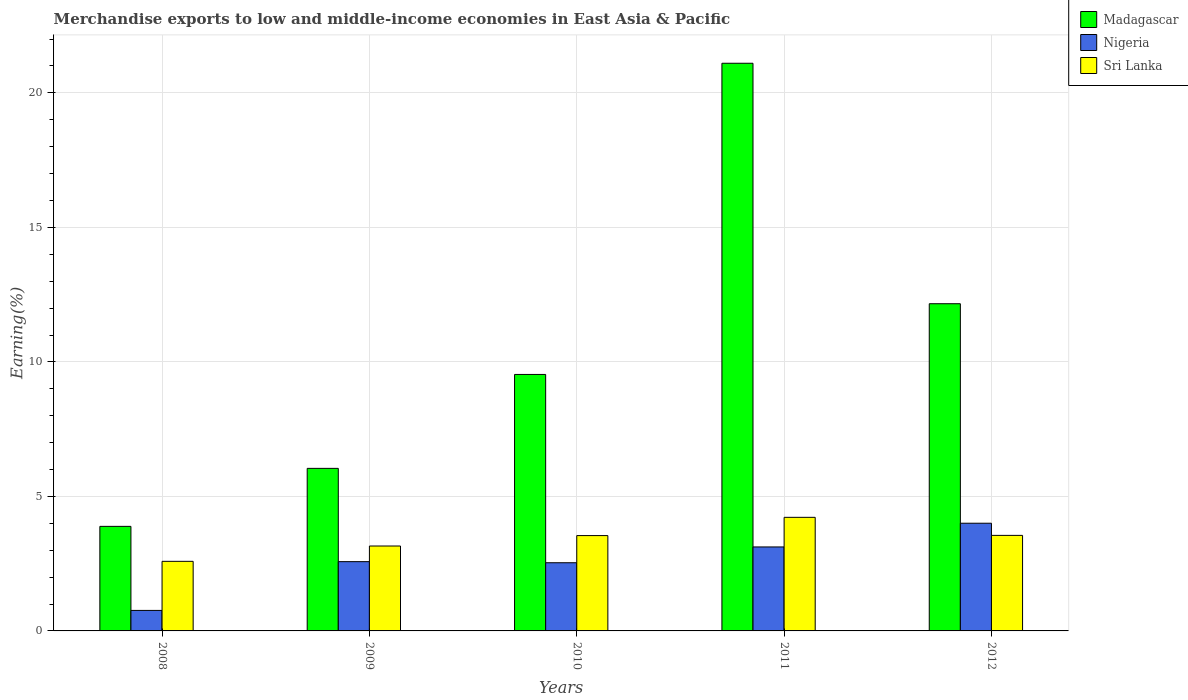How many different coloured bars are there?
Provide a short and direct response. 3. Are the number of bars per tick equal to the number of legend labels?
Your response must be concise. Yes. Are the number of bars on each tick of the X-axis equal?
Ensure brevity in your answer.  Yes. How many bars are there on the 4th tick from the left?
Your response must be concise. 3. How many bars are there on the 2nd tick from the right?
Your answer should be very brief. 3. What is the label of the 4th group of bars from the left?
Your answer should be compact. 2011. What is the percentage of amount earned from merchandise exports in Sri Lanka in 2008?
Give a very brief answer. 2.59. Across all years, what is the maximum percentage of amount earned from merchandise exports in Nigeria?
Offer a terse response. 4. Across all years, what is the minimum percentage of amount earned from merchandise exports in Nigeria?
Make the answer very short. 0.76. What is the total percentage of amount earned from merchandise exports in Sri Lanka in the graph?
Offer a terse response. 17.06. What is the difference between the percentage of amount earned from merchandise exports in Sri Lanka in 2008 and that in 2012?
Ensure brevity in your answer.  -0.96. What is the difference between the percentage of amount earned from merchandise exports in Madagascar in 2011 and the percentage of amount earned from merchandise exports in Nigeria in 2010?
Offer a terse response. 18.57. What is the average percentage of amount earned from merchandise exports in Nigeria per year?
Provide a succinct answer. 2.6. In the year 2010, what is the difference between the percentage of amount earned from merchandise exports in Madagascar and percentage of amount earned from merchandise exports in Nigeria?
Your response must be concise. 7. In how many years, is the percentage of amount earned from merchandise exports in Sri Lanka greater than 14 %?
Ensure brevity in your answer.  0. What is the ratio of the percentage of amount earned from merchandise exports in Madagascar in 2009 to that in 2011?
Provide a succinct answer. 0.29. What is the difference between the highest and the second highest percentage of amount earned from merchandise exports in Nigeria?
Make the answer very short. 0.88. What is the difference between the highest and the lowest percentage of amount earned from merchandise exports in Sri Lanka?
Provide a succinct answer. 1.64. Is the sum of the percentage of amount earned from merchandise exports in Nigeria in 2009 and 2010 greater than the maximum percentage of amount earned from merchandise exports in Sri Lanka across all years?
Your answer should be compact. Yes. What does the 2nd bar from the left in 2008 represents?
Give a very brief answer. Nigeria. What does the 2nd bar from the right in 2008 represents?
Provide a succinct answer. Nigeria. How many bars are there?
Offer a very short reply. 15. Are all the bars in the graph horizontal?
Provide a succinct answer. No. Does the graph contain grids?
Your answer should be very brief. Yes. Where does the legend appear in the graph?
Keep it short and to the point. Top right. How many legend labels are there?
Ensure brevity in your answer.  3. What is the title of the graph?
Make the answer very short. Merchandise exports to low and middle-income economies in East Asia & Pacific. What is the label or title of the Y-axis?
Give a very brief answer. Earning(%). What is the Earning(%) in Madagascar in 2008?
Ensure brevity in your answer.  3.89. What is the Earning(%) in Nigeria in 2008?
Give a very brief answer. 0.76. What is the Earning(%) of Sri Lanka in 2008?
Keep it short and to the point. 2.59. What is the Earning(%) of Madagascar in 2009?
Your response must be concise. 6.04. What is the Earning(%) in Nigeria in 2009?
Make the answer very short. 2.57. What is the Earning(%) of Sri Lanka in 2009?
Your answer should be compact. 3.16. What is the Earning(%) in Madagascar in 2010?
Your answer should be compact. 9.53. What is the Earning(%) of Nigeria in 2010?
Make the answer very short. 2.53. What is the Earning(%) of Sri Lanka in 2010?
Provide a succinct answer. 3.54. What is the Earning(%) in Madagascar in 2011?
Provide a succinct answer. 21.1. What is the Earning(%) of Nigeria in 2011?
Make the answer very short. 3.12. What is the Earning(%) of Sri Lanka in 2011?
Your answer should be compact. 4.22. What is the Earning(%) in Madagascar in 2012?
Keep it short and to the point. 12.16. What is the Earning(%) of Nigeria in 2012?
Your response must be concise. 4. What is the Earning(%) in Sri Lanka in 2012?
Your answer should be very brief. 3.55. Across all years, what is the maximum Earning(%) in Madagascar?
Your answer should be very brief. 21.1. Across all years, what is the maximum Earning(%) in Nigeria?
Your answer should be compact. 4. Across all years, what is the maximum Earning(%) of Sri Lanka?
Provide a short and direct response. 4.22. Across all years, what is the minimum Earning(%) of Madagascar?
Your answer should be compact. 3.89. Across all years, what is the minimum Earning(%) of Nigeria?
Ensure brevity in your answer.  0.76. Across all years, what is the minimum Earning(%) in Sri Lanka?
Ensure brevity in your answer.  2.59. What is the total Earning(%) of Madagascar in the graph?
Ensure brevity in your answer.  52.73. What is the total Earning(%) in Nigeria in the graph?
Your answer should be compact. 13. What is the total Earning(%) in Sri Lanka in the graph?
Ensure brevity in your answer.  17.06. What is the difference between the Earning(%) of Madagascar in 2008 and that in 2009?
Offer a very short reply. -2.16. What is the difference between the Earning(%) in Nigeria in 2008 and that in 2009?
Provide a short and direct response. -1.81. What is the difference between the Earning(%) in Sri Lanka in 2008 and that in 2009?
Your answer should be compact. -0.57. What is the difference between the Earning(%) of Madagascar in 2008 and that in 2010?
Ensure brevity in your answer.  -5.65. What is the difference between the Earning(%) of Nigeria in 2008 and that in 2010?
Ensure brevity in your answer.  -1.77. What is the difference between the Earning(%) of Sri Lanka in 2008 and that in 2010?
Offer a very short reply. -0.96. What is the difference between the Earning(%) in Madagascar in 2008 and that in 2011?
Make the answer very short. -17.22. What is the difference between the Earning(%) of Nigeria in 2008 and that in 2011?
Your answer should be very brief. -2.36. What is the difference between the Earning(%) in Sri Lanka in 2008 and that in 2011?
Make the answer very short. -1.64. What is the difference between the Earning(%) in Madagascar in 2008 and that in 2012?
Your response must be concise. -8.28. What is the difference between the Earning(%) in Nigeria in 2008 and that in 2012?
Provide a short and direct response. -3.24. What is the difference between the Earning(%) in Sri Lanka in 2008 and that in 2012?
Your answer should be compact. -0.96. What is the difference between the Earning(%) in Madagascar in 2009 and that in 2010?
Keep it short and to the point. -3.49. What is the difference between the Earning(%) in Nigeria in 2009 and that in 2010?
Give a very brief answer. 0.04. What is the difference between the Earning(%) in Sri Lanka in 2009 and that in 2010?
Offer a terse response. -0.39. What is the difference between the Earning(%) in Madagascar in 2009 and that in 2011?
Give a very brief answer. -15.06. What is the difference between the Earning(%) of Nigeria in 2009 and that in 2011?
Your answer should be very brief. -0.55. What is the difference between the Earning(%) in Sri Lanka in 2009 and that in 2011?
Your response must be concise. -1.07. What is the difference between the Earning(%) in Madagascar in 2009 and that in 2012?
Offer a terse response. -6.12. What is the difference between the Earning(%) of Nigeria in 2009 and that in 2012?
Your answer should be compact. -1.43. What is the difference between the Earning(%) in Sri Lanka in 2009 and that in 2012?
Your response must be concise. -0.39. What is the difference between the Earning(%) in Madagascar in 2010 and that in 2011?
Offer a very short reply. -11.57. What is the difference between the Earning(%) of Nigeria in 2010 and that in 2011?
Provide a short and direct response. -0.59. What is the difference between the Earning(%) in Sri Lanka in 2010 and that in 2011?
Make the answer very short. -0.68. What is the difference between the Earning(%) of Madagascar in 2010 and that in 2012?
Your answer should be compact. -2.63. What is the difference between the Earning(%) of Nigeria in 2010 and that in 2012?
Your answer should be very brief. -1.47. What is the difference between the Earning(%) of Sri Lanka in 2010 and that in 2012?
Your answer should be very brief. -0.01. What is the difference between the Earning(%) of Madagascar in 2011 and that in 2012?
Your response must be concise. 8.94. What is the difference between the Earning(%) of Nigeria in 2011 and that in 2012?
Offer a very short reply. -0.88. What is the difference between the Earning(%) in Sri Lanka in 2011 and that in 2012?
Make the answer very short. 0.67. What is the difference between the Earning(%) of Madagascar in 2008 and the Earning(%) of Nigeria in 2009?
Offer a very short reply. 1.31. What is the difference between the Earning(%) of Madagascar in 2008 and the Earning(%) of Sri Lanka in 2009?
Ensure brevity in your answer.  0.73. What is the difference between the Earning(%) in Nigeria in 2008 and the Earning(%) in Sri Lanka in 2009?
Your answer should be compact. -2.39. What is the difference between the Earning(%) of Madagascar in 2008 and the Earning(%) of Nigeria in 2010?
Offer a very short reply. 1.35. What is the difference between the Earning(%) in Madagascar in 2008 and the Earning(%) in Sri Lanka in 2010?
Ensure brevity in your answer.  0.34. What is the difference between the Earning(%) in Nigeria in 2008 and the Earning(%) in Sri Lanka in 2010?
Make the answer very short. -2.78. What is the difference between the Earning(%) of Madagascar in 2008 and the Earning(%) of Nigeria in 2011?
Keep it short and to the point. 0.76. What is the difference between the Earning(%) in Madagascar in 2008 and the Earning(%) in Sri Lanka in 2011?
Your response must be concise. -0.34. What is the difference between the Earning(%) in Nigeria in 2008 and the Earning(%) in Sri Lanka in 2011?
Offer a very short reply. -3.46. What is the difference between the Earning(%) in Madagascar in 2008 and the Earning(%) in Nigeria in 2012?
Keep it short and to the point. -0.12. What is the difference between the Earning(%) in Madagascar in 2008 and the Earning(%) in Sri Lanka in 2012?
Give a very brief answer. 0.34. What is the difference between the Earning(%) of Nigeria in 2008 and the Earning(%) of Sri Lanka in 2012?
Your answer should be compact. -2.79. What is the difference between the Earning(%) in Madagascar in 2009 and the Earning(%) in Nigeria in 2010?
Your answer should be compact. 3.51. What is the difference between the Earning(%) in Madagascar in 2009 and the Earning(%) in Sri Lanka in 2010?
Ensure brevity in your answer.  2.5. What is the difference between the Earning(%) in Nigeria in 2009 and the Earning(%) in Sri Lanka in 2010?
Give a very brief answer. -0.97. What is the difference between the Earning(%) of Madagascar in 2009 and the Earning(%) of Nigeria in 2011?
Keep it short and to the point. 2.92. What is the difference between the Earning(%) of Madagascar in 2009 and the Earning(%) of Sri Lanka in 2011?
Your answer should be compact. 1.82. What is the difference between the Earning(%) in Nigeria in 2009 and the Earning(%) in Sri Lanka in 2011?
Provide a succinct answer. -1.65. What is the difference between the Earning(%) in Madagascar in 2009 and the Earning(%) in Nigeria in 2012?
Provide a short and direct response. 2.04. What is the difference between the Earning(%) in Madagascar in 2009 and the Earning(%) in Sri Lanka in 2012?
Your response must be concise. 2.49. What is the difference between the Earning(%) in Nigeria in 2009 and the Earning(%) in Sri Lanka in 2012?
Give a very brief answer. -0.98. What is the difference between the Earning(%) of Madagascar in 2010 and the Earning(%) of Nigeria in 2011?
Make the answer very short. 6.41. What is the difference between the Earning(%) of Madagascar in 2010 and the Earning(%) of Sri Lanka in 2011?
Offer a very short reply. 5.31. What is the difference between the Earning(%) of Nigeria in 2010 and the Earning(%) of Sri Lanka in 2011?
Your answer should be compact. -1.69. What is the difference between the Earning(%) in Madagascar in 2010 and the Earning(%) in Nigeria in 2012?
Ensure brevity in your answer.  5.53. What is the difference between the Earning(%) in Madagascar in 2010 and the Earning(%) in Sri Lanka in 2012?
Make the answer very short. 5.98. What is the difference between the Earning(%) of Nigeria in 2010 and the Earning(%) of Sri Lanka in 2012?
Provide a short and direct response. -1.02. What is the difference between the Earning(%) in Madagascar in 2011 and the Earning(%) in Nigeria in 2012?
Keep it short and to the point. 17.1. What is the difference between the Earning(%) of Madagascar in 2011 and the Earning(%) of Sri Lanka in 2012?
Provide a short and direct response. 17.55. What is the difference between the Earning(%) of Nigeria in 2011 and the Earning(%) of Sri Lanka in 2012?
Provide a succinct answer. -0.43. What is the average Earning(%) in Madagascar per year?
Make the answer very short. 10.55. What is the average Earning(%) in Nigeria per year?
Provide a short and direct response. 2.6. What is the average Earning(%) of Sri Lanka per year?
Your response must be concise. 3.41. In the year 2008, what is the difference between the Earning(%) in Madagascar and Earning(%) in Nigeria?
Ensure brevity in your answer.  3.12. In the year 2008, what is the difference between the Earning(%) of Madagascar and Earning(%) of Sri Lanka?
Offer a terse response. 1.3. In the year 2008, what is the difference between the Earning(%) in Nigeria and Earning(%) in Sri Lanka?
Make the answer very short. -1.82. In the year 2009, what is the difference between the Earning(%) of Madagascar and Earning(%) of Nigeria?
Keep it short and to the point. 3.47. In the year 2009, what is the difference between the Earning(%) in Madagascar and Earning(%) in Sri Lanka?
Offer a very short reply. 2.89. In the year 2009, what is the difference between the Earning(%) in Nigeria and Earning(%) in Sri Lanka?
Offer a very short reply. -0.58. In the year 2010, what is the difference between the Earning(%) of Madagascar and Earning(%) of Nigeria?
Offer a terse response. 7. In the year 2010, what is the difference between the Earning(%) of Madagascar and Earning(%) of Sri Lanka?
Your response must be concise. 5.99. In the year 2010, what is the difference between the Earning(%) of Nigeria and Earning(%) of Sri Lanka?
Keep it short and to the point. -1.01. In the year 2011, what is the difference between the Earning(%) in Madagascar and Earning(%) in Nigeria?
Provide a short and direct response. 17.98. In the year 2011, what is the difference between the Earning(%) of Madagascar and Earning(%) of Sri Lanka?
Your answer should be very brief. 16.88. In the year 2011, what is the difference between the Earning(%) of Nigeria and Earning(%) of Sri Lanka?
Your answer should be compact. -1.1. In the year 2012, what is the difference between the Earning(%) in Madagascar and Earning(%) in Nigeria?
Your answer should be very brief. 8.16. In the year 2012, what is the difference between the Earning(%) in Madagascar and Earning(%) in Sri Lanka?
Offer a very short reply. 8.61. In the year 2012, what is the difference between the Earning(%) of Nigeria and Earning(%) of Sri Lanka?
Ensure brevity in your answer.  0.45. What is the ratio of the Earning(%) of Madagascar in 2008 to that in 2009?
Ensure brevity in your answer.  0.64. What is the ratio of the Earning(%) in Nigeria in 2008 to that in 2009?
Offer a terse response. 0.3. What is the ratio of the Earning(%) in Sri Lanka in 2008 to that in 2009?
Your response must be concise. 0.82. What is the ratio of the Earning(%) of Madagascar in 2008 to that in 2010?
Provide a short and direct response. 0.41. What is the ratio of the Earning(%) of Nigeria in 2008 to that in 2010?
Offer a very short reply. 0.3. What is the ratio of the Earning(%) of Sri Lanka in 2008 to that in 2010?
Provide a succinct answer. 0.73. What is the ratio of the Earning(%) of Madagascar in 2008 to that in 2011?
Provide a succinct answer. 0.18. What is the ratio of the Earning(%) of Nigeria in 2008 to that in 2011?
Your answer should be compact. 0.24. What is the ratio of the Earning(%) in Sri Lanka in 2008 to that in 2011?
Keep it short and to the point. 0.61. What is the ratio of the Earning(%) in Madagascar in 2008 to that in 2012?
Provide a short and direct response. 0.32. What is the ratio of the Earning(%) of Nigeria in 2008 to that in 2012?
Provide a succinct answer. 0.19. What is the ratio of the Earning(%) in Sri Lanka in 2008 to that in 2012?
Give a very brief answer. 0.73. What is the ratio of the Earning(%) of Madagascar in 2009 to that in 2010?
Your answer should be very brief. 0.63. What is the ratio of the Earning(%) in Sri Lanka in 2009 to that in 2010?
Provide a succinct answer. 0.89. What is the ratio of the Earning(%) of Madagascar in 2009 to that in 2011?
Provide a short and direct response. 0.29. What is the ratio of the Earning(%) of Nigeria in 2009 to that in 2011?
Offer a terse response. 0.82. What is the ratio of the Earning(%) in Sri Lanka in 2009 to that in 2011?
Make the answer very short. 0.75. What is the ratio of the Earning(%) in Madagascar in 2009 to that in 2012?
Make the answer very short. 0.5. What is the ratio of the Earning(%) in Nigeria in 2009 to that in 2012?
Provide a succinct answer. 0.64. What is the ratio of the Earning(%) of Madagascar in 2010 to that in 2011?
Offer a very short reply. 0.45. What is the ratio of the Earning(%) of Nigeria in 2010 to that in 2011?
Your response must be concise. 0.81. What is the ratio of the Earning(%) in Sri Lanka in 2010 to that in 2011?
Ensure brevity in your answer.  0.84. What is the ratio of the Earning(%) of Madagascar in 2010 to that in 2012?
Provide a succinct answer. 0.78. What is the ratio of the Earning(%) of Nigeria in 2010 to that in 2012?
Give a very brief answer. 0.63. What is the ratio of the Earning(%) in Madagascar in 2011 to that in 2012?
Provide a succinct answer. 1.73. What is the ratio of the Earning(%) of Nigeria in 2011 to that in 2012?
Offer a terse response. 0.78. What is the ratio of the Earning(%) of Sri Lanka in 2011 to that in 2012?
Offer a very short reply. 1.19. What is the difference between the highest and the second highest Earning(%) in Madagascar?
Make the answer very short. 8.94. What is the difference between the highest and the second highest Earning(%) of Nigeria?
Your answer should be very brief. 0.88. What is the difference between the highest and the second highest Earning(%) of Sri Lanka?
Provide a short and direct response. 0.67. What is the difference between the highest and the lowest Earning(%) in Madagascar?
Ensure brevity in your answer.  17.22. What is the difference between the highest and the lowest Earning(%) of Nigeria?
Provide a succinct answer. 3.24. What is the difference between the highest and the lowest Earning(%) of Sri Lanka?
Provide a short and direct response. 1.64. 